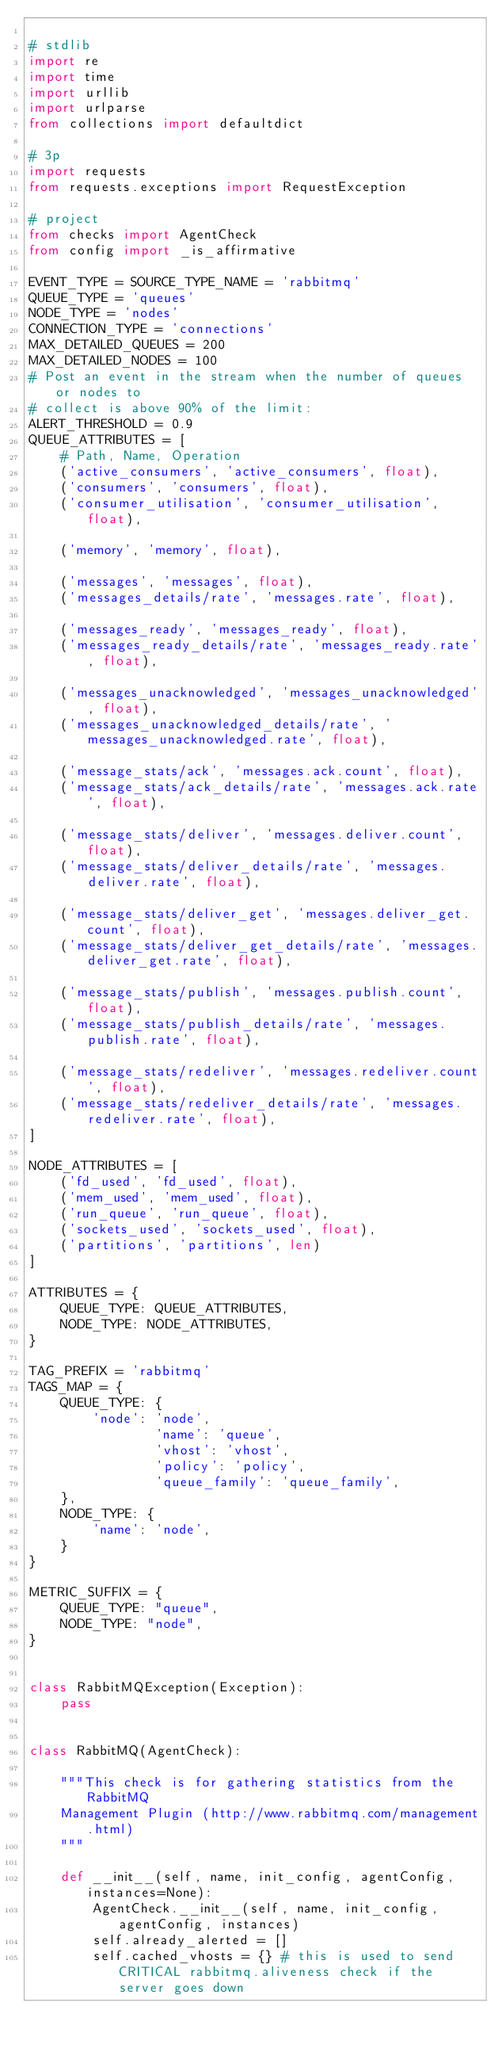<code> <loc_0><loc_0><loc_500><loc_500><_Python_>
# stdlib
import re
import time
import urllib
import urlparse
from collections import defaultdict

# 3p
import requests
from requests.exceptions import RequestException

# project
from checks import AgentCheck
from config import _is_affirmative

EVENT_TYPE = SOURCE_TYPE_NAME = 'rabbitmq'
QUEUE_TYPE = 'queues'
NODE_TYPE = 'nodes'
CONNECTION_TYPE = 'connections'
MAX_DETAILED_QUEUES = 200
MAX_DETAILED_NODES = 100
# Post an event in the stream when the number of queues or nodes to
# collect is above 90% of the limit:
ALERT_THRESHOLD = 0.9
QUEUE_ATTRIBUTES = [
    # Path, Name, Operation
    ('active_consumers', 'active_consumers', float),
    ('consumers', 'consumers', float),
    ('consumer_utilisation', 'consumer_utilisation', float),

    ('memory', 'memory', float),

    ('messages', 'messages', float),
    ('messages_details/rate', 'messages.rate', float),

    ('messages_ready', 'messages_ready', float),
    ('messages_ready_details/rate', 'messages_ready.rate', float),

    ('messages_unacknowledged', 'messages_unacknowledged', float),
    ('messages_unacknowledged_details/rate', 'messages_unacknowledged.rate', float),

    ('message_stats/ack', 'messages.ack.count', float),
    ('message_stats/ack_details/rate', 'messages.ack.rate', float),

    ('message_stats/deliver', 'messages.deliver.count', float),
    ('message_stats/deliver_details/rate', 'messages.deliver.rate', float),

    ('message_stats/deliver_get', 'messages.deliver_get.count', float),
    ('message_stats/deliver_get_details/rate', 'messages.deliver_get.rate', float),

    ('message_stats/publish', 'messages.publish.count', float),
    ('message_stats/publish_details/rate', 'messages.publish.rate', float),

    ('message_stats/redeliver', 'messages.redeliver.count', float),
    ('message_stats/redeliver_details/rate', 'messages.redeliver.rate', float),
]

NODE_ATTRIBUTES = [
    ('fd_used', 'fd_used', float),
    ('mem_used', 'mem_used', float),
    ('run_queue', 'run_queue', float),
    ('sockets_used', 'sockets_used', float),
    ('partitions', 'partitions', len)
]

ATTRIBUTES = {
    QUEUE_TYPE: QUEUE_ATTRIBUTES,
    NODE_TYPE: NODE_ATTRIBUTES,
}

TAG_PREFIX = 'rabbitmq'
TAGS_MAP = {
    QUEUE_TYPE: {
        'node': 'node',
                'name': 'queue',
                'vhost': 'vhost',
                'policy': 'policy',
                'queue_family': 'queue_family',
    },
    NODE_TYPE: {
        'name': 'node',
    }
}

METRIC_SUFFIX = {
    QUEUE_TYPE: "queue",
    NODE_TYPE: "node",
}


class RabbitMQException(Exception):
    pass


class RabbitMQ(AgentCheck):

    """This check is for gathering statistics from the RabbitMQ
    Management Plugin (http://www.rabbitmq.com/management.html)
    """

    def __init__(self, name, init_config, agentConfig, instances=None):
        AgentCheck.__init__(self, name, init_config, agentConfig, instances)
        self.already_alerted = []
        self.cached_vhosts = {} # this is used to send CRITICAL rabbitmq.aliveness check if the server goes down
</code> 